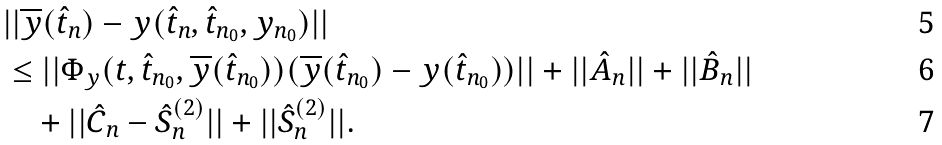Convert formula to latex. <formula><loc_0><loc_0><loc_500><loc_500>& | | \overline { y } ( \hat { t } _ { n } ) - y ( \hat { t } _ { n } , \hat { t } _ { n _ { 0 } } , y _ { n _ { 0 } } ) | | \\ & \leq | | \Phi _ { y } ( t , \hat { t } _ { n _ { 0 } } , \overline { y } ( \hat { t } _ { n _ { 0 } } ) ) ( \overline { y } ( \hat { t } _ { n _ { 0 } } ) - y ( \hat { t } _ { n _ { 0 } } ) ) | | + | | \hat { A } _ { n } | | + | | \hat { B } _ { n } | | \\ & \quad + | | \hat { C } _ { n } - \hat { S } _ { n } ^ { ( 2 ) } | | + | | \hat { S } _ { n } ^ { ( 2 ) } | | .</formula> 